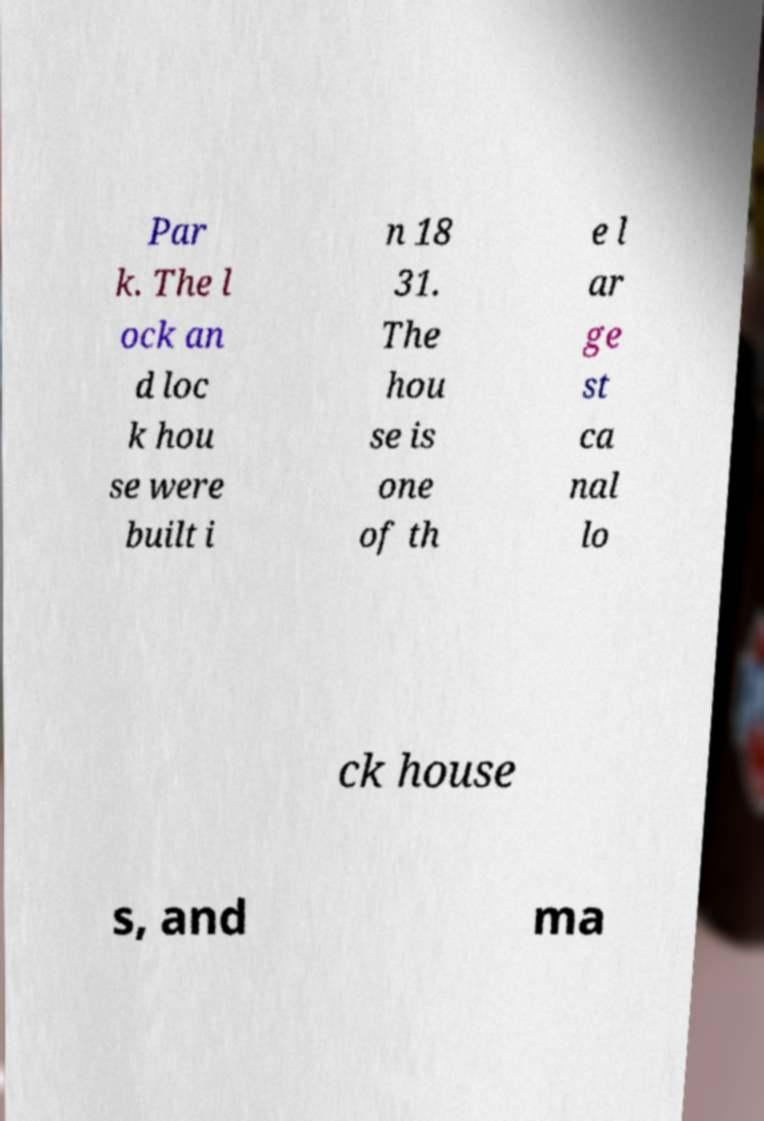Could you extract and type out the text from this image? Par k. The l ock an d loc k hou se were built i n 18 31. The hou se is one of th e l ar ge st ca nal lo ck house s, and ma 